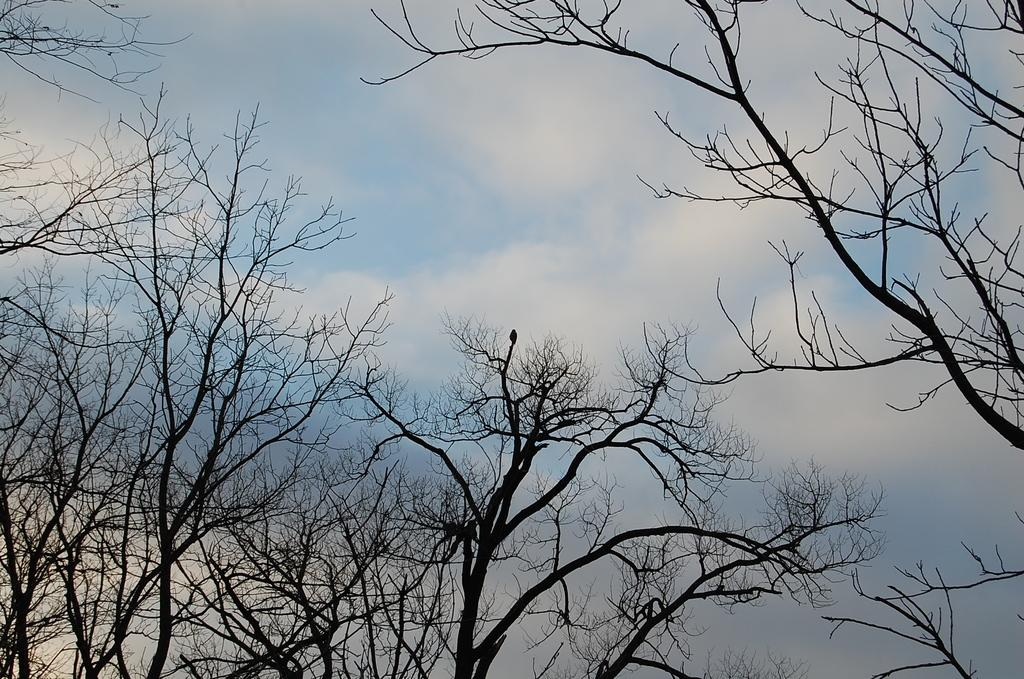What type of vegetation can be seen in the image? There are trees in the image. Where are the trees located in relation to the image? The trees are in the foreground of the image. What can be seen in the background of the image? The sky is visible in the background of the image. What type of haircut does the leaf have in the image? There is no leaf present in the image, and therefore no haircut can be observed. 